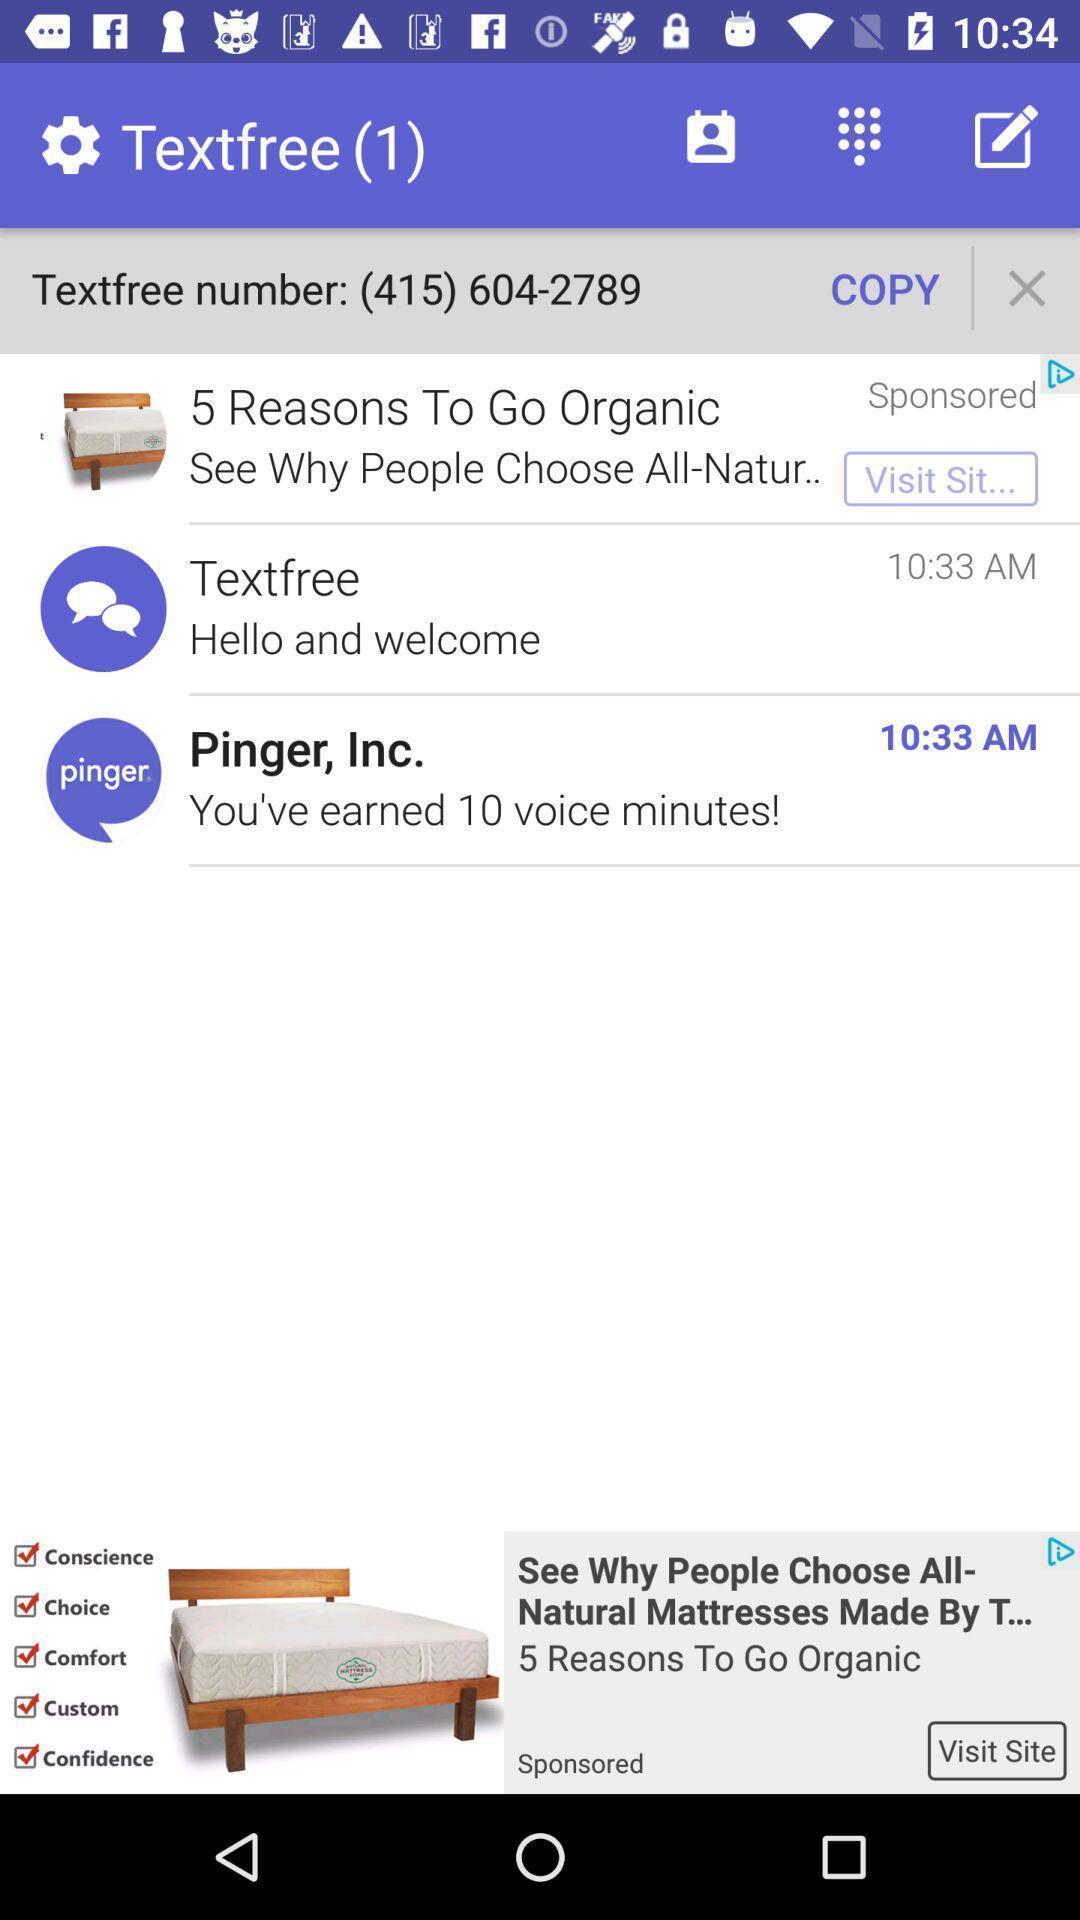Explain what's happening in this screen capture. Screen displaying various messages. 